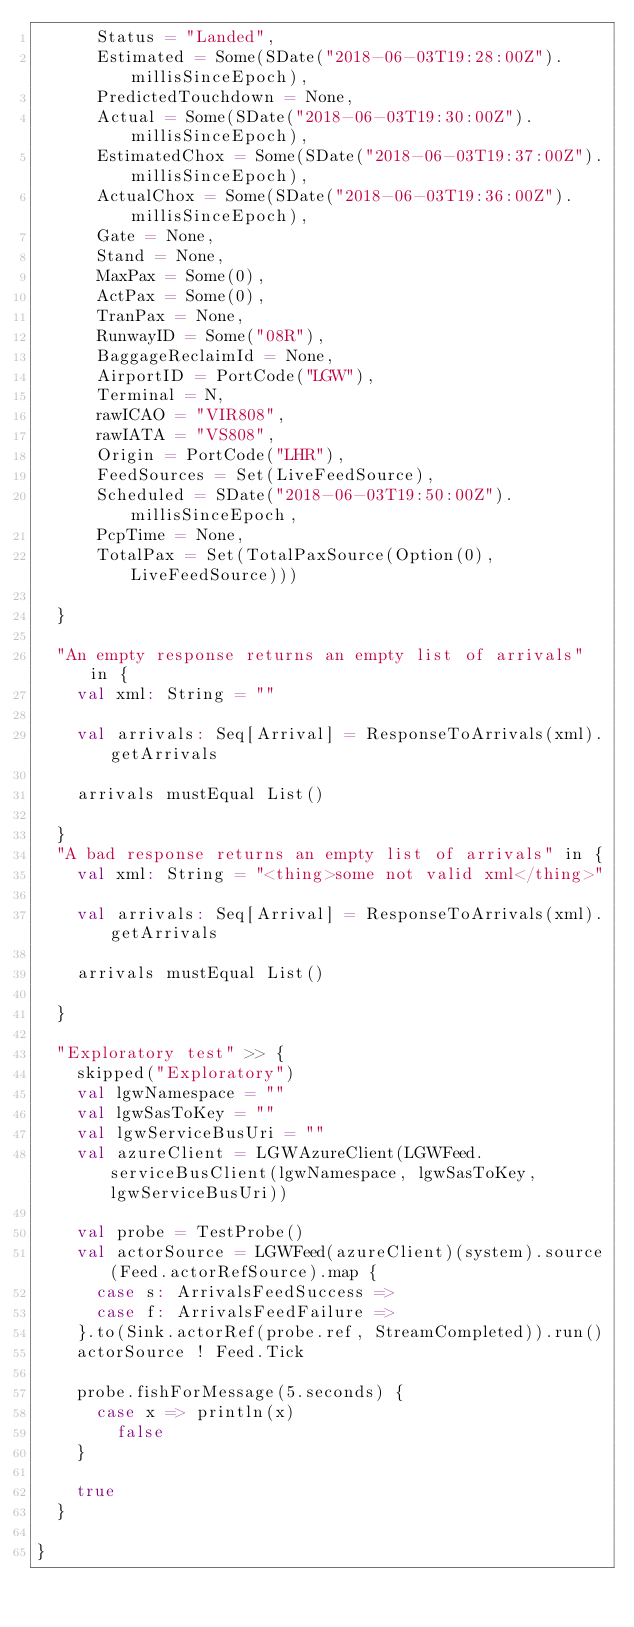Convert code to text. <code><loc_0><loc_0><loc_500><loc_500><_Scala_>      Status = "Landed",
      Estimated = Some(SDate("2018-06-03T19:28:00Z").millisSinceEpoch),
      PredictedTouchdown = None,
      Actual = Some(SDate("2018-06-03T19:30:00Z").millisSinceEpoch),
      EstimatedChox = Some(SDate("2018-06-03T19:37:00Z").millisSinceEpoch),
      ActualChox = Some(SDate("2018-06-03T19:36:00Z").millisSinceEpoch),
      Gate = None,
      Stand = None,
      MaxPax = Some(0),
      ActPax = Some(0),
      TranPax = None,
      RunwayID = Some("08R"),
      BaggageReclaimId = None,
      AirportID = PortCode("LGW"),
      Terminal = N,
      rawICAO = "VIR808",
      rawIATA = "VS808",
      Origin = PortCode("LHR"),
      FeedSources = Set(LiveFeedSource),
      Scheduled = SDate("2018-06-03T19:50:00Z").millisSinceEpoch,
      PcpTime = None,
      TotalPax = Set(TotalPaxSource(Option(0), LiveFeedSource)))

  }

  "An empty response returns an empty list of arrivals" in {
    val xml: String = ""

    val arrivals: Seq[Arrival] = ResponseToArrivals(xml).getArrivals

    arrivals mustEqual List()

  }
  "A bad response returns an empty list of arrivals" in {
    val xml: String = "<thing>some not valid xml</thing>"

    val arrivals: Seq[Arrival] = ResponseToArrivals(xml).getArrivals

    arrivals mustEqual List()

  }

  "Exploratory test" >> {
    skipped("Exploratory")
    val lgwNamespace = ""
    val lgwSasToKey = ""
    val lgwServiceBusUri = ""
    val azureClient = LGWAzureClient(LGWFeed.serviceBusClient(lgwNamespace, lgwSasToKey, lgwServiceBusUri))

    val probe = TestProbe()
    val actorSource = LGWFeed(azureClient)(system).source(Feed.actorRefSource).map {
      case s: ArrivalsFeedSuccess =>
      case f: ArrivalsFeedFailure =>
    }.to(Sink.actorRef(probe.ref, StreamCompleted)).run()
    actorSource ! Feed.Tick

    probe.fishForMessage(5.seconds) {
      case x => println(x)
        false
    }

    true
  }

}
</code> 